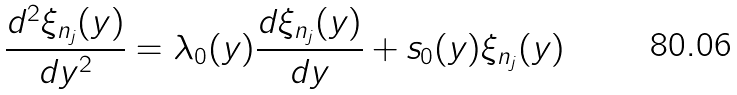Convert formula to latex. <formula><loc_0><loc_0><loc_500><loc_500>\frac { d ^ { 2 } \xi _ { n _ { j } } ( y ) } { d y ^ { 2 } } = \lambda _ { 0 } ( y ) \frac { d \xi _ { n _ { j } } ( y ) } { d y } + s _ { 0 } ( y ) \xi _ { n _ { j } } ( y )</formula> 